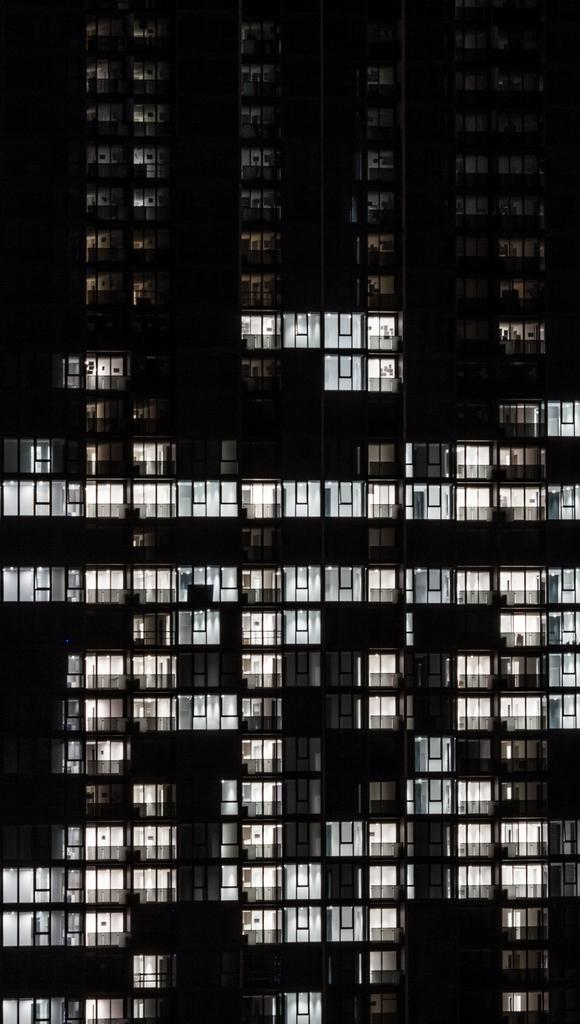What type of structures can be seen in the image? There are windows of buildings visible in the image. What feature do the windows have? The windows have lights. How would you describe the overall appearance of the image? The image has a dark appearance. What type of pollution can be seen in the image? There is no pollution visible in the image; it only shows windows of buildings with lights. 